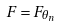<formula> <loc_0><loc_0><loc_500><loc_500>F = F _ { \theta _ { n } }</formula> 